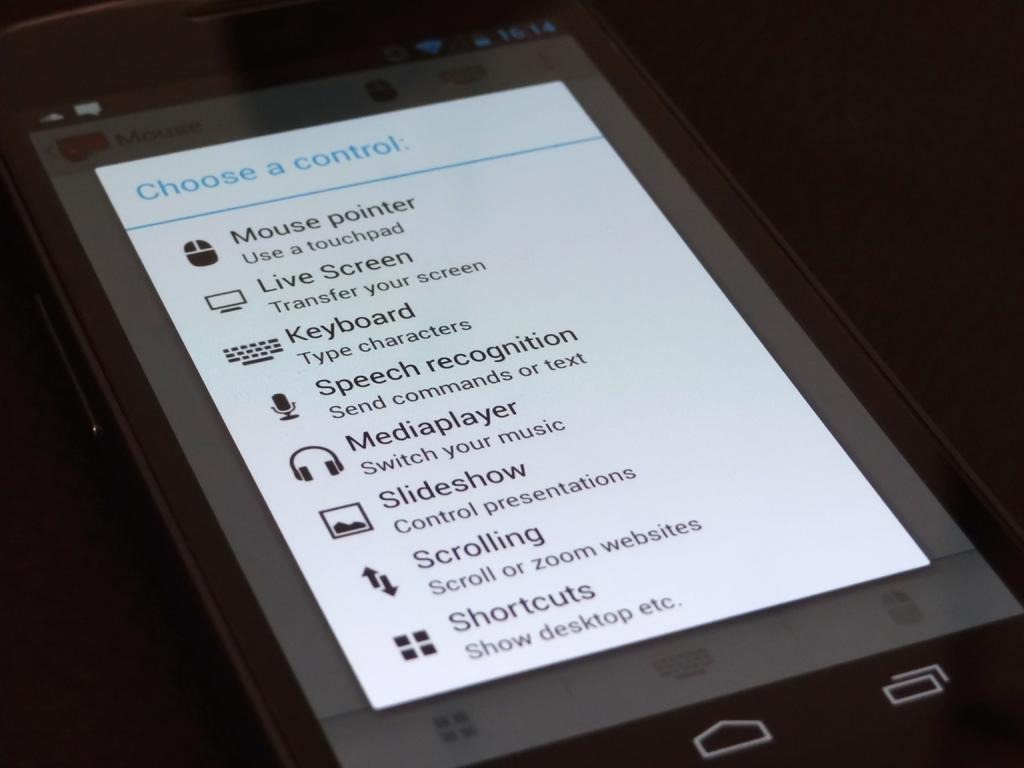<image>
Summarize the visual content of the image. a tablet with the phrase choose a control written in blue at the top 